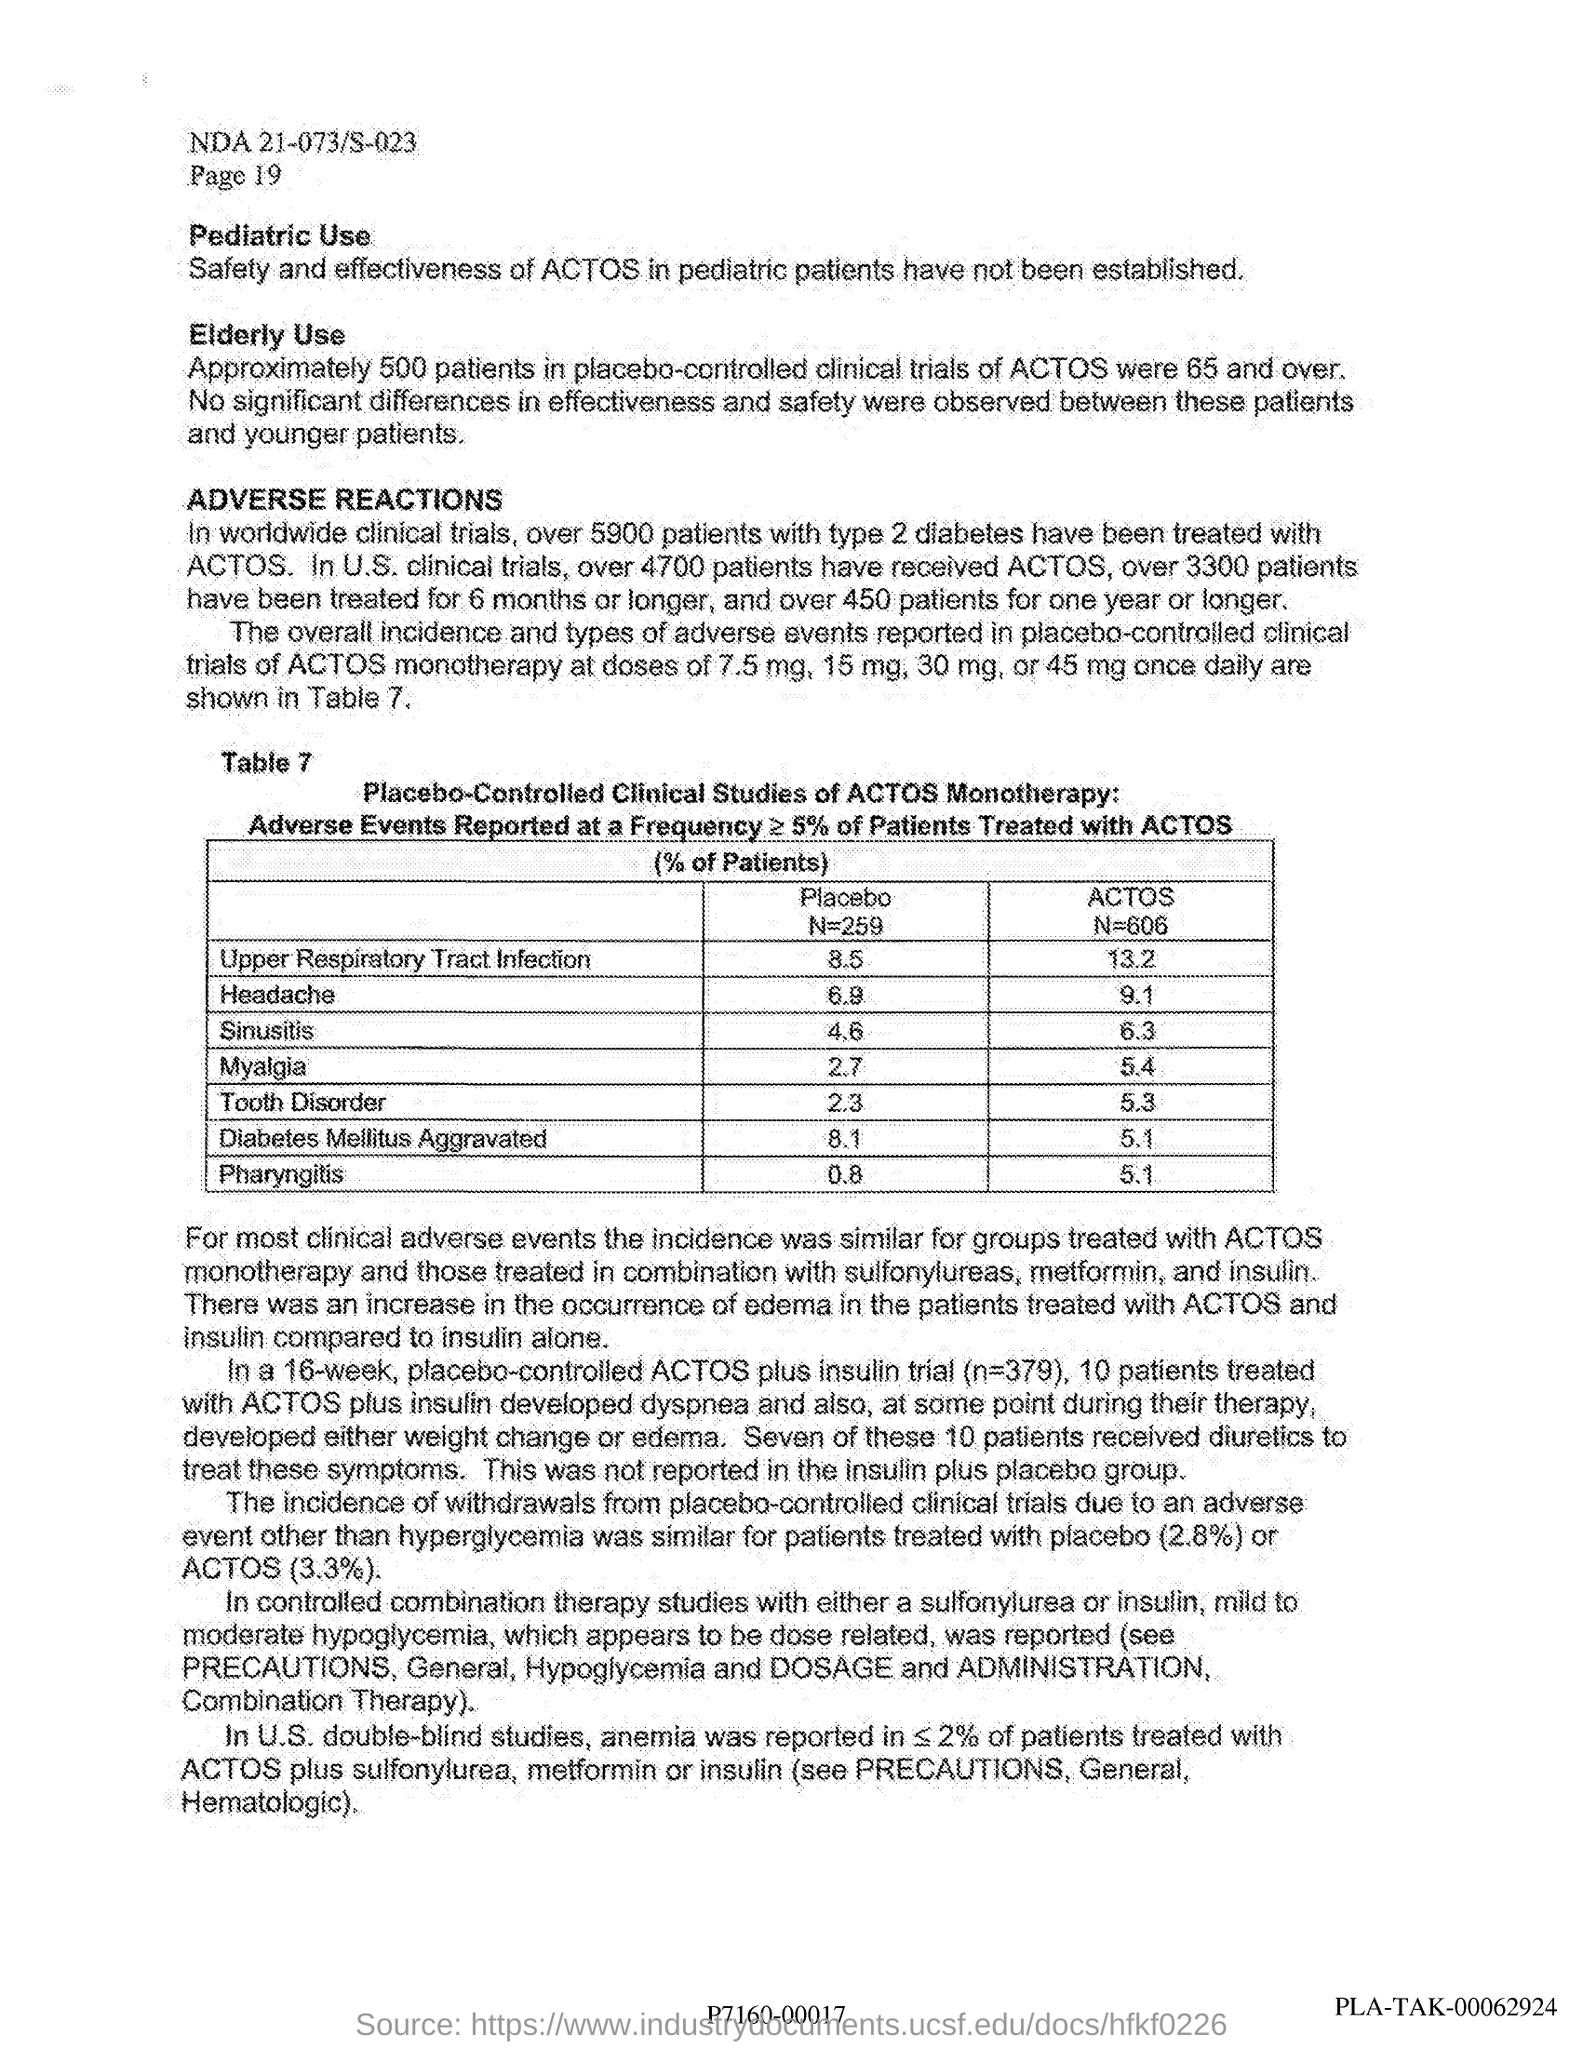Give some essential details in this illustration. In US clinical trials, over 4700 patients have received ACTOS. Actos, a medication, has been used to treat type 2 diabetes in over 5,900 patients. 